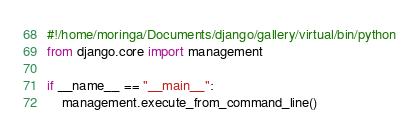Convert code to text. <code><loc_0><loc_0><loc_500><loc_500><_Python_>#!/home/moringa/Documents/django/gallery/virtual/bin/python
from django.core import management

if __name__ == "__main__":
    management.execute_from_command_line()
</code> 